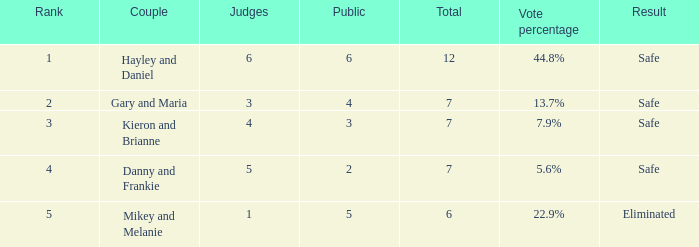How many public is there for the couple that got eliminated? 5.0. 